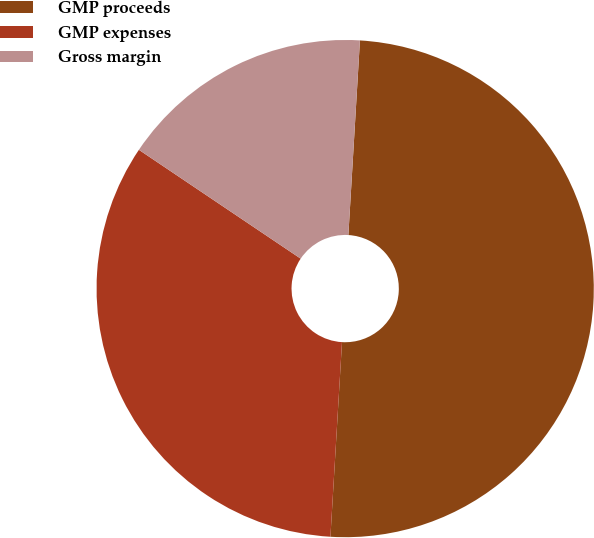Convert chart. <chart><loc_0><loc_0><loc_500><loc_500><pie_chart><fcel>GMP proceeds<fcel>GMP expenses<fcel>Gross margin<nl><fcel>50.0%<fcel>33.48%<fcel>16.52%<nl></chart> 